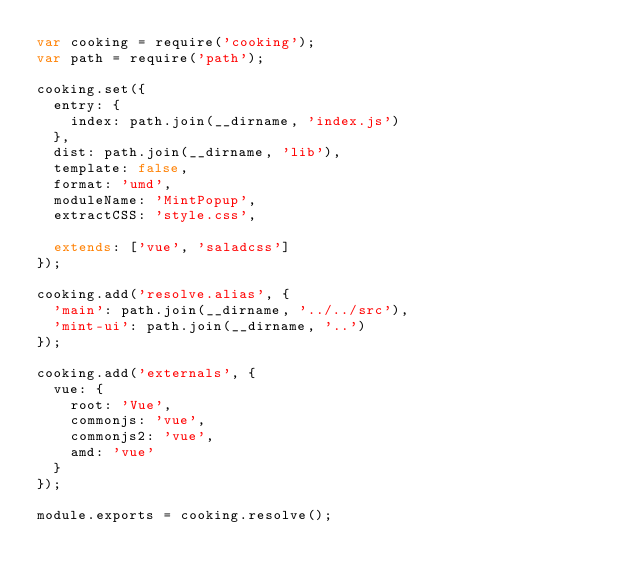<code> <loc_0><loc_0><loc_500><loc_500><_JavaScript_>var cooking = require('cooking');
var path = require('path');

cooking.set({
  entry: {
    index: path.join(__dirname, 'index.js')
  },
  dist: path.join(__dirname, 'lib'),
  template: false,
  format: 'umd',
  moduleName: 'MintPopup',
  extractCSS: 'style.css',

  extends: ['vue', 'saladcss']
});

cooking.add('resolve.alias', {
  'main': path.join(__dirname, '../../src'),
  'mint-ui': path.join(__dirname, '..')
});

cooking.add('externals', {
  vue: {
    root: 'Vue',
    commonjs: 'vue',
    commonjs2: 'vue',
    amd: 'vue'
  }
});

module.exports = cooking.resolve();
</code> 